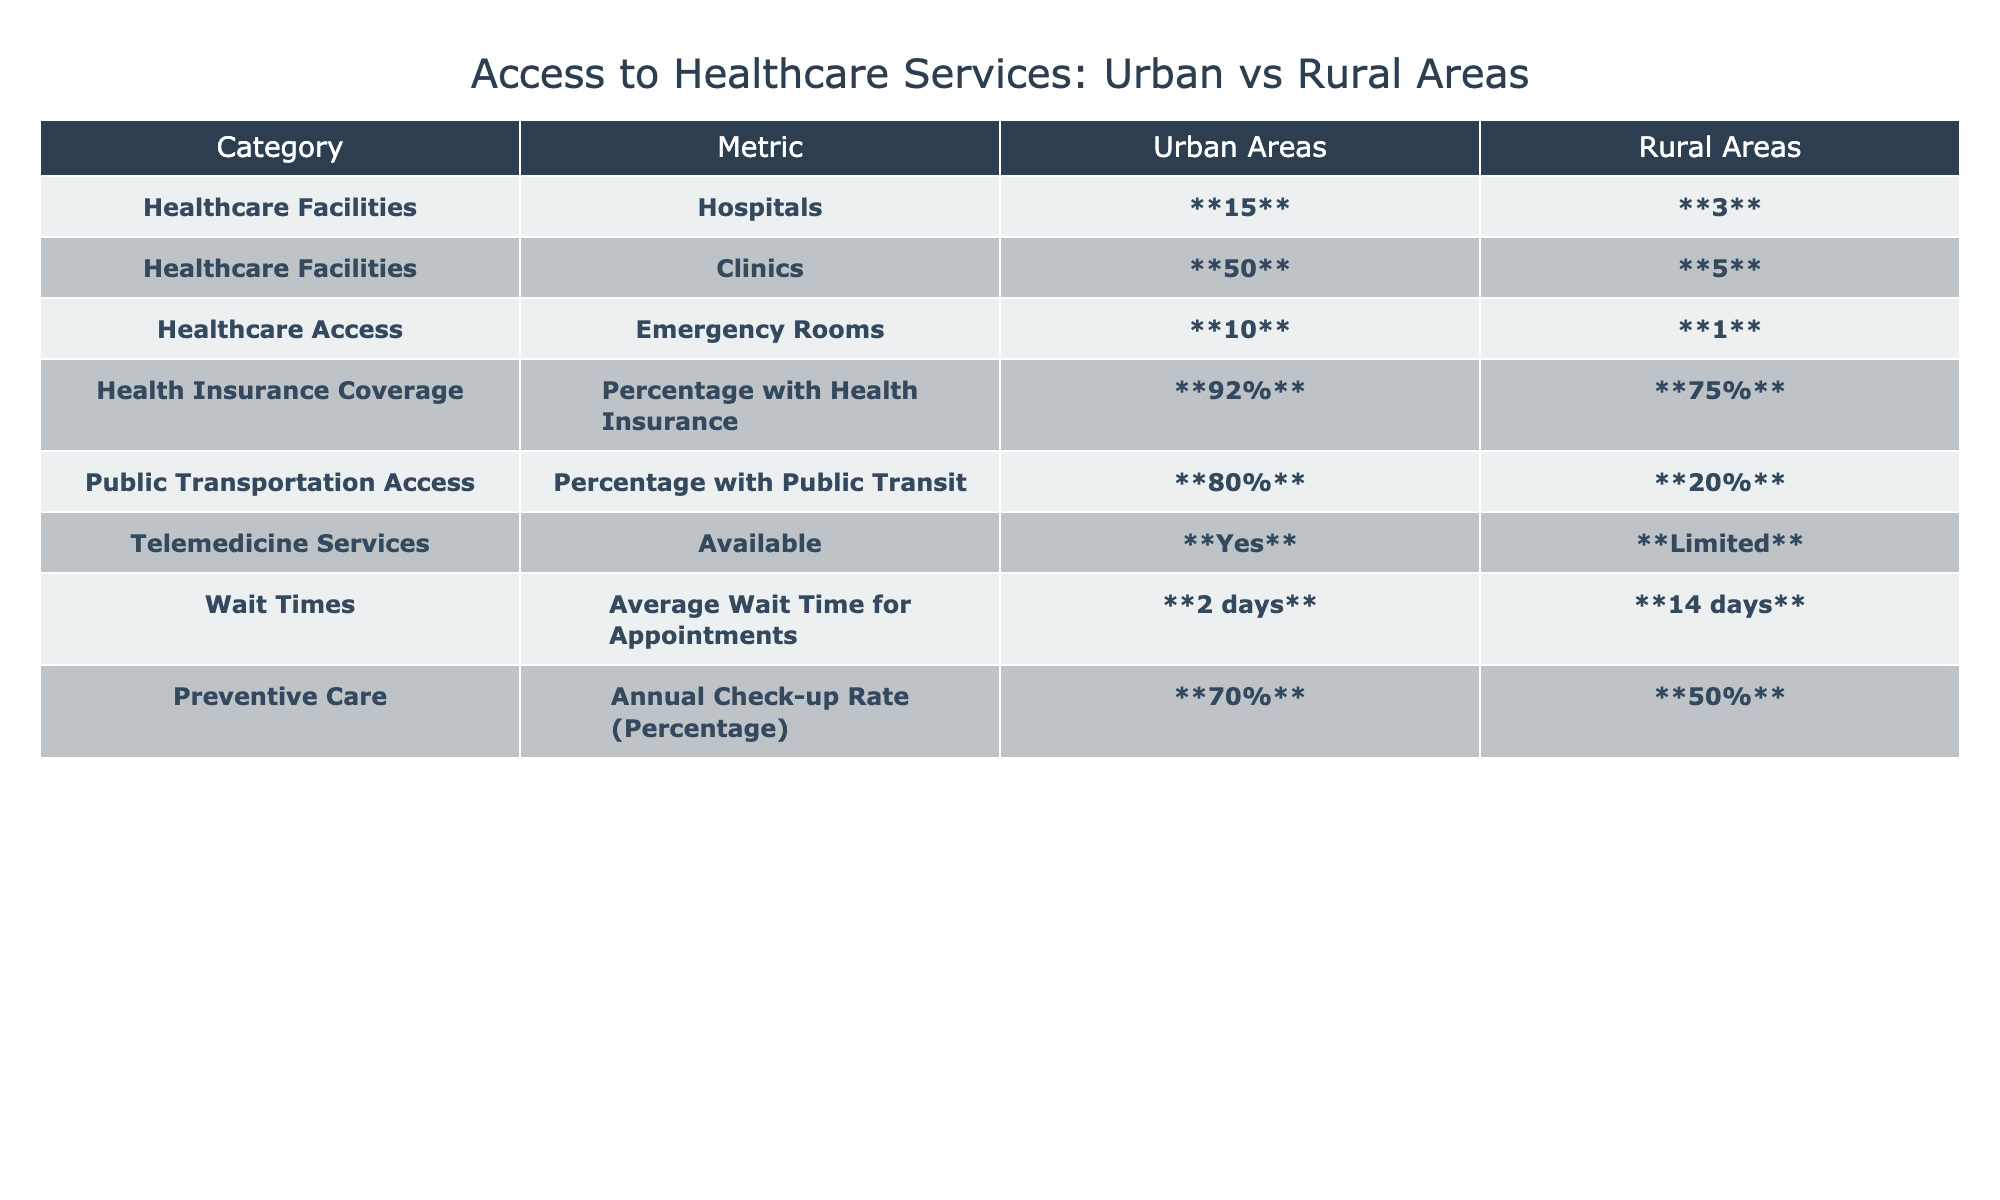What is the total number of hospitals in urban areas? The table shows that there are 15 hospitals in urban areas.
Answer: 15 What is the difference in the number of clinics between urban and rural areas? In urban areas, there are 50 clinics and in rural areas, there are 5 clinics. The difference is 50 - 5 = 45.
Answer: 45 Is telemedicine available in rural areas? The table indicates that telemedicine services are limited in rural areas.
Answer: No What is the average wait time for appointments in rural areas compared to urban areas? The average wait time in urban areas is 2 days and in rural areas is 14 days. The difference is 14 - 2 = 12 days longer in rural areas.
Answer: 12 days What percentage of people in urban areas have health insurance? According to the table, 92% of people in urban areas have health insurance.
Answer: 92% How much higher is the percentage of health insurance coverage in urban areas than in rural areas? Urban areas have 92% coverage while rural areas have 75%. The difference is 92% - 75% = 17%.
Answer: 17% Are emergency rooms more accessible in urban areas? There are 10 emergency rooms in urban areas compared to only 1 in rural areas, indicating that urban areas have better access.
Answer: Yes What is the ratio of healthcare facilities (hospitals and clinics combined) in urban areas to rural areas? Urban areas have 15 hospitals and 50 clinics, totaling 65, while rural areas have 3 hospitals and 5 clinics, totaling 8. The ratio is 65:8 or simplified to about 8.125:1.
Answer: 8.125:1 What percentage of rural residents have access to public transit? The table states that 20% of rural residents have access to public transit.
Answer: 20% Is the wait time for appointments shorter in urban areas than in rural areas? The average wait time in urban areas is 2 days, while in rural areas it is 14 days, showing that urban wait times are shorter.
Answer: Yes What is the percentage of annual check-up rates for preventive care in urban areas? According to the table, 70% of people in urban areas have their annual check-ups.
Answer: 70% 